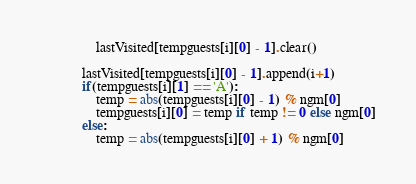<code> <loc_0><loc_0><loc_500><loc_500><_Python_>                lastVisited[tempguests[i][0] - 1].clear()

            lastVisited[tempguests[i][0] - 1].append(i+1)
            if(tempguests[i][1] == 'A'):
                temp = abs(tempguests[i][0] - 1) % ngm[0]
                tempguests[i][0] = temp if temp != 0 else ngm[0]
            else:
                temp = abs(tempguests[i][0] + 1) % ngm[0]</code> 